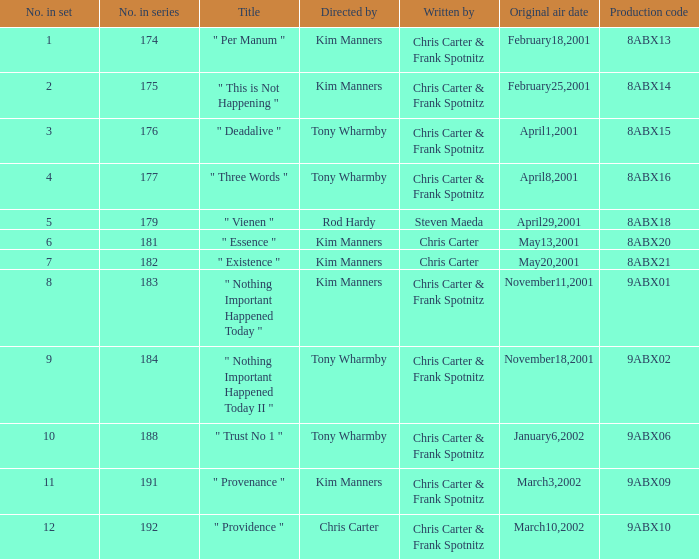Which episode carries the production code 8abx15? 176.0. 